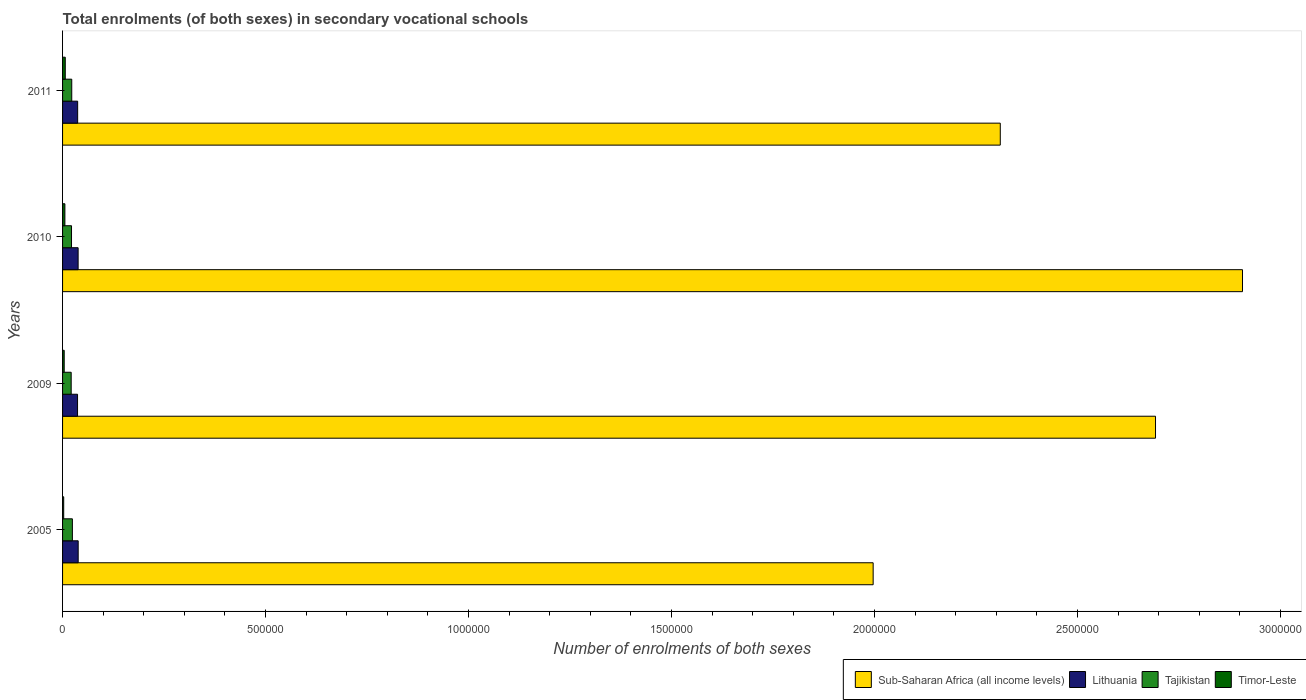How many different coloured bars are there?
Make the answer very short. 4. Are the number of bars on each tick of the Y-axis equal?
Your answer should be compact. Yes. What is the number of enrolments in secondary schools in Tajikistan in 2010?
Ensure brevity in your answer.  2.20e+04. Across all years, what is the maximum number of enrolments in secondary schools in Sub-Saharan Africa (all income levels)?
Your answer should be compact. 2.91e+06. Across all years, what is the minimum number of enrolments in secondary schools in Sub-Saharan Africa (all income levels)?
Give a very brief answer. 2.00e+06. In which year was the number of enrolments in secondary schools in Timor-Leste maximum?
Give a very brief answer. 2011. What is the total number of enrolments in secondary schools in Tajikistan in the graph?
Provide a short and direct response. 9.01e+04. What is the difference between the number of enrolments in secondary schools in Lithuania in 2009 and that in 2010?
Give a very brief answer. -1429. What is the difference between the number of enrolments in secondary schools in Timor-Leste in 2005 and the number of enrolments in secondary schools in Sub-Saharan Africa (all income levels) in 2009?
Provide a short and direct response. -2.69e+06. What is the average number of enrolments in secondary schools in Lithuania per year?
Your answer should be very brief. 3.77e+04. In the year 2005, what is the difference between the number of enrolments in secondary schools in Sub-Saharan Africa (all income levels) and number of enrolments in secondary schools in Tajikistan?
Offer a terse response. 1.97e+06. In how many years, is the number of enrolments in secondary schools in Tajikistan greater than 2900000 ?
Your answer should be compact. 0. What is the ratio of the number of enrolments in secondary schools in Lithuania in 2009 to that in 2011?
Keep it short and to the point. 0.99. Is the number of enrolments in secondary schools in Timor-Leste in 2009 less than that in 2011?
Your response must be concise. Yes. Is the difference between the number of enrolments in secondary schools in Sub-Saharan Africa (all income levels) in 2009 and 2010 greater than the difference between the number of enrolments in secondary schools in Tajikistan in 2009 and 2010?
Keep it short and to the point. No. What is the difference between the highest and the second highest number of enrolments in secondary schools in Timor-Leste?
Ensure brevity in your answer.  930. What is the difference between the highest and the lowest number of enrolments in secondary schools in Lithuania?
Give a very brief answer. 1573. Is it the case that in every year, the sum of the number of enrolments in secondary schools in Sub-Saharan Africa (all income levels) and number of enrolments in secondary schools in Tajikistan is greater than the sum of number of enrolments in secondary schools in Lithuania and number of enrolments in secondary schools in Timor-Leste?
Offer a terse response. Yes. What does the 3rd bar from the top in 2010 represents?
Your answer should be compact. Lithuania. What does the 4th bar from the bottom in 2011 represents?
Provide a short and direct response. Timor-Leste. Is it the case that in every year, the sum of the number of enrolments in secondary schools in Lithuania and number of enrolments in secondary schools in Sub-Saharan Africa (all income levels) is greater than the number of enrolments in secondary schools in Tajikistan?
Ensure brevity in your answer.  Yes. How many bars are there?
Offer a very short reply. 16. What is the difference between two consecutive major ticks on the X-axis?
Offer a terse response. 5.00e+05. Does the graph contain any zero values?
Offer a terse response. No. Does the graph contain grids?
Your response must be concise. No. Where does the legend appear in the graph?
Provide a short and direct response. Bottom right. How many legend labels are there?
Make the answer very short. 4. How are the legend labels stacked?
Offer a very short reply. Horizontal. What is the title of the graph?
Provide a short and direct response. Total enrolments (of both sexes) in secondary vocational schools. Does "Latin America(developing only)" appear as one of the legend labels in the graph?
Provide a short and direct response. No. What is the label or title of the X-axis?
Keep it short and to the point. Number of enrolments of both sexes. What is the Number of enrolments of both sexes in Sub-Saharan Africa (all income levels) in 2005?
Make the answer very short. 2.00e+06. What is the Number of enrolments of both sexes in Lithuania in 2005?
Offer a terse response. 3.85e+04. What is the Number of enrolments of both sexes in Tajikistan in 2005?
Keep it short and to the point. 2.42e+04. What is the Number of enrolments of both sexes in Timor-Leste in 2005?
Keep it short and to the point. 2800. What is the Number of enrolments of both sexes in Sub-Saharan Africa (all income levels) in 2009?
Give a very brief answer. 2.69e+06. What is the Number of enrolments of both sexes in Lithuania in 2009?
Your answer should be very brief. 3.69e+04. What is the Number of enrolments of both sexes of Tajikistan in 2009?
Provide a succinct answer. 2.12e+04. What is the Number of enrolments of both sexes in Timor-Leste in 2009?
Ensure brevity in your answer.  4044. What is the Number of enrolments of both sexes of Sub-Saharan Africa (all income levels) in 2010?
Ensure brevity in your answer.  2.91e+06. What is the Number of enrolments of both sexes in Lithuania in 2010?
Keep it short and to the point. 3.83e+04. What is the Number of enrolments of both sexes in Tajikistan in 2010?
Give a very brief answer. 2.20e+04. What is the Number of enrolments of both sexes of Timor-Leste in 2010?
Your answer should be compact. 5719. What is the Number of enrolments of both sexes in Sub-Saharan Africa (all income levels) in 2011?
Your answer should be very brief. 2.31e+06. What is the Number of enrolments of both sexes of Lithuania in 2011?
Provide a succinct answer. 3.72e+04. What is the Number of enrolments of both sexes in Tajikistan in 2011?
Keep it short and to the point. 2.26e+04. What is the Number of enrolments of both sexes in Timor-Leste in 2011?
Your answer should be compact. 6649. Across all years, what is the maximum Number of enrolments of both sexes of Sub-Saharan Africa (all income levels)?
Offer a terse response. 2.91e+06. Across all years, what is the maximum Number of enrolments of both sexes of Lithuania?
Offer a very short reply. 3.85e+04. Across all years, what is the maximum Number of enrolments of both sexes in Tajikistan?
Make the answer very short. 2.42e+04. Across all years, what is the maximum Number of enrolments of both sexes in Timor-Leste?
Your answer should be compact. 6649. Across all years, what is the minimum Number of enrolments of both sexes in Sub-Saharan Africa (all income levels)?
Provide a succinct answer. 2.00e+06. Across all years, what is the minimum Number of enrolments of both sexes of Lithuania?
Keep it short and to the point. 3.69e+04. Across all years, what is the minimum Number of enrolments of both sexes of Tajikistan?
Keep it short and to the point. 2.12e+04. Across all years, what is the minimum Number of enrolments of both sexes of Timor-Leste?
Give a very brief answer. 2800. What is the total Number of enrolments of both sexes in Sub-Saharan Africa (all income levels) in the graph?
Provide a short and direct response. 9.91e+06. What is the total Number of enrolments of both sexes of Lithuania in the graph?
Your answer should be compact. 1.51e+05. What is the total Number of enrolments of both sexes in Tajikistan in the graph?
Provide a short and direct response. 9.01e+04. What is the total Number of enrolments of both sexes in Timor-Leste in the graph?
Your answer should be compact. 1.92e+04. What is the difference between the Number of enrolments of both sexes in Sub-Saharan Africa (all income levels) in 2005 and that in 2009?
Provide a succinct answer. -6.96e+05. What is the difference between the Number of enrolments of both sexes in Lithuania in 2005 and that in 2009?
Provide a succinct answer. 1573. What is the difference between the Number of enrolments of both sexes in Tajikistan in 2005 and that in 2009?
Ensure brevity in your answer.  2952. What is the difference between the Number of enrolments of both sexes in Timor-Leste in 2005 and that in 2009?
Offer a terse response. -1244. What is the difference between the Number of enrolments of both sexes in Sub-Saharan Africa (all income levels) in 2005 and that in 2010?
Offer a very short reply. -9.10e+05. What is the difference between the Number of enrolments of both sexes of Lithuania in 2005 and that in 2010?
Provide a short and direct response. 144. What is the difference between the Number of enrolments of both sexes of Tajikistan in 2005 and that in 2010?
Offer a very short reply. 2167. What is the difference between the Number of enrolments of both sexes in Timor-Leste in 2005 and that in 2010?
Keep it short and to the point. -2919. What is the difference between the Number of enrolments of both sexes of Sub-Saharan Africa (all income levels) in 2005 and that in 2011?
Provide a succinct answer. -3.13e+05. What is the difference between the Number of enrolments of both sexes of Lithuania in 2005 and that in 2011?
Offer a terse response. 1291. What is the difference between the Number of enrolments of both sexes of Tajikistan in 2005 and that in 2011?
Offer a terse response. 1565. What is the difference between the Number of enrolments of both sexes of Timor-Leste in 2005 and that in 2011?
Your answer should be compact. -3849. What is the difference between the Number of enrolments of both sexes of Sub-Saharan Africa (all income levels) in 2009 and that in 2010?
Provide a succinct answer. -2.14e+05. What is the difference between the Number of enrolments of both sexes of Lithuania in 2009 and that in 2010?
Make the answer very short. -1429. What is the difference between the Number of enrolments of both sexes of Tajikistan in 2009 and that in 2010?
Your response must be concise. -785. What is the difference between the Number of enrolments of both sexes of Timor-Leste in 2009 and that in 2010?
Offer a very short reply. -1675. What is the difference between the Number of enrolments of both sexes of Sub-Saharan Africa (all income levels) in 2009 and that in 2011?
Keep it short and to the point. 3.82e+05. What is the difference between the Number of enrolments of both sexes of Lithuania in 2009 and that in 2011?
Your answer should be compact. -282. What is the difference between the Number of enrolments of both sexes in Tajikistan in 2009 and that in 2011?
Ensure brevity in your answer.  -1387. What is the difference between the Number of enrolments of both sexes of Timor-Leste in 2009 and that in 2011?
Keep it short and to the point. -2605. What is the difference between the Number of enrolments of both sexes in Sub-Saharan Africa (all income levels) in 2010 and that in 2011?
Your answer should be compact. 5.97e+05. What is the difference between the Number of enrolments of both sexes in Lithuania in 2010 and that in 2011?
Keep it short and to the point. 1147. What is the difference between the Number of enrolments of both sexes in Tajikistan in 2010 and that in 2011?
Keep it short and to the point. -602. What is the difference between the Number of enrolments of both sexes of Timor-Leste in 2010 and that in 2011?
Ensure brevity in your answer.  -930. What is the difference between the Number of enrolments of both sexes of Sub-Saharan Africa (all income levels) in 2005 and the Number of enrolments of both sexes of Lithuania in 2009?
Provide a succinct answer. 1.96e+06. What is the difference between the Number of enrolments of both sexes of Sub-Saharan Africa (all income levels) in 2005 and the Number of enrolments of both sexes of Tajikistan in 2009?
Your response must be concise. 1.98e+06. What is the difference between the Number of enrolments of both sexes of Sub-Saharan Africa (all income levels) in 2005 and the Number of enrolments of both sexes of Timor-Leste in 2009?
Offer a terse response. 1.99e+06. What is the difference between the Number of enrolments of both sexes in Lithuania in 2005 and the Number of enrolments of both sexes in Tajikistan in 2009?
Provide a succinct answer. 1.72e+04. What is the difference between the Number of enrolments of both sexes of Lithuania in 2005 and the Number of enrolments of both sexes of Timor-Leste in 2009?
Give a very brief answer. 3.44e+04. What is the difference between the Number of enrolments of both sexes in Tajikistan in 2005 and the Number of enrolments of both sexes in Timor-Leste in 2009?
Keep it short and to the point. 2.02e+04. What is the difference between the Number of enrolments of both sexes in Sub-Saharan Africa (all income levels) in 2005 and the Number of enrolments of both sexes in Lithuania in 2010?
Keep it short and to the point. 1.96e+06. What is the difference between the Number of enrolments of both sexes of Sub-Saharan Africa (all income levels) in 2005 and the Number of enrolments of both sexes of Tajikistan in 2010?
Your answer should be compact. 1.97e+06. What is the difference between the Number of enrolments of both sexes of Sub-Saharan Africa (all income levels) in 2005 and the Number of enrolments of both sexes of Timor-Leste in 2010?
Your response must be concise. 1.99e+06. What is the difference between the Number of enrolments of both sexes of Lithuania in 2005 and the Number of enrolments of both sexes of Tajikistan in 2010?
Offer a terse response. 1.64e+04. What is the difference between the Number of enrolments of both sexes of Lithuania in 2005 and the Number of enrolments of both sexes of Timor-Leste in 2010?
Provide a short and direct response. 3.27e+04. What is the difference between the Number of enrolments of both sexes of Tajikistan in 2005 and the Number of enrolments of both sexes of Timor-Leste in 2010?
Offer a terse response. 1.85e+04. What is the difference between the Number of enrolments of both sexes of Sub-Saharan Africa (all income levels) in 2005 and the Number of enrolments of both sexes of Lithuania in 2011?
Give a very brief answer. 1.96e+06. What is the difference between the Number of enrolments of both sexes in Sub-Saharan Africa (all income levels) in 2005 and the Number of enrolments of both sexes in Tajikistan in 2011?
Your response must be concise. 1.97e+06. What is the difference between the Number of enrolments of both sexes in Sub-Saharan Africa (all income levels) in 2005 and the Number of enrolments of both sexes in Timor-Leste in 2011?
Offer a very short reply. 1.99e+06. What is the difference between the Number of enrolments of both sexes in Lithuania in 2005 and the Number of enrolments of both sexes in Tajikistan in 2011?
Your answer should be very brief. 1.58e+04. What is the difference between the Number of enrolments of both sexes in Lithuania in 2005 and the Number of enrolments of both sexes in Timor-Leste in 2011?
Keep it short and to the point. 3.18e+04. What is the difference between the Number of enrolments of both sexes of Tajikistan in 2005 and the Number of enrolments of both sexes of Timor-Leste in 2011?
Offer a terse response. 1.75e+04. What is the difference between the Number of enrolments of both sexes in Sub-Saharan Africa (all income levels) in 2009 and the Number of enrolments of both sexes in Lithuania in 2010?
Offer a terse response. 2.65e+06. What is the difference between the Number of enrolments of both sexes in Sub-Saharan Africa (all income levels) in 2009 and the Number of enrolments of both sexes in Tajikistan in 2010?
Keep it short and to the point. 2.67e+06. What is the difference between the Number of enrolments of both sexes of Sub-Saharan Africa (all income levels) in 2009 and the Number of enrolments of both sexes of Timor-Leste in 2010?
Offer a terse response. 2.69e+06. What is the difference between the Number of enrolments of both sexes of Lithuania in 2009 and the Number of enrolments of both sexes of Tajikistan in 2010?
Ensure brevity in your answer.  1.49e+04. What is the difference between the Number of enrolments of both sexes in Lithuania in 2009 and the Number of enrolments of both sexes in Timor-Leste in 2010?
Offer a terse response. 3.12e+04. What is the difference between the Number of enrolments of both sexes of Tajikistan in 2009 and the Number of enrolments of both sexes of Timor-Leste in 2010?
Give a very brief answer. 1.55e+04. What is the difference between the Number of enrolments of both sexes in Sub-Saharan Africa (all income levels) in 2009 and the Number of enrolments of both sexes in Lithuania in 2011?
Give a very brief answer. 2.66e+06. What is the difference between the Number of enrolments of both sexes of Sub-Saharan Africa (all income levels) in 2009 and the Number of enrolments of both sexes of Tajikistan in 2011?
Provide a succinct answer. 2.67e+06. What is the difference between the Number of enrolments of both sexes in Sub-Saharan Africa (all income levels) in 2009 and the Number of enrolments of both sexes in Timor-Leste in 2011?
Ensure brevity in your answer.  2.69e+06. What is the difference between the Number of enrolments of both sexes of Lithuania in 2009 and the Number of enrolments of both sexes of Tajikistan in 2011?
Provide a succinct answer. 1.43e+04. What is the difference between the Number of enrolments of both sexes in Lithuania in 2009 and the Number of enrolments of both sexes in Timor-Leste in 2011?
Your answer should be compact. 3.02e+04. What is the difference between the Number of enrolments of both sexes of Tajikistan in 2009 and the Number of enrolments of both sexes of Timor-Leste in 2011?
Your answer should be compact. 1.46e+04. What is the difference between the Number of enrolments of both sexes in Sub-Saharan Africa (all income levels) in 2010 and the Number of enrolments of both sexes in Lithuania in 2011?
Ensure brevity in your answer.  2.87e+06. What is the difference between the Number of enrolments of both sexes in Sub-Saharan Africa (all income levels) in 2010 and the Number of enrolments of both sexes in Tajikistan in 2011?
Keep it short and to the point. 2.88e+06. What is the difference between the Number of enrolments of both sexes in Sub-Saharan Africa (all income levels) in 2010 and the Number of enrolments of both sexes in Timor-Leste in 2011?
Ensure brevity in your answer.  2.90e+06. What is the difference between the Number of enrolments of both sexes of Lithuania in 2010 and the Number of enrolments of both sexes of Tajikistan in 2011?
Your answer should be very brief. 1.57e+04. What is the difference between the Number of enrolments of both sexes of Lithuania in 2010 and the Number of enrolments of both sexes of Timor-Leste in 2011?
Make the answer very short. 3.17e+04. What is the difference between the Number of enrolments of both sexes of Tajikistan in 2010 and the Number of enrolments of both sexes of Timor-Leste in 2011?
Offer a terse response. 1.54e+04. What is the average Number of enrolments of both sexes in Sub-Saharan Africa (all income levels) per year?
Your answer should be compact. 2.48e+06. What is the average Number of enrolments of both sexes in Lithuania per year?
Make the answer very short. 3.77e+04. What is the average Number of enrolments of both sexes in Tajikistan per year?
Your answer should be very brief. 2.25e+04. What is the average Number of enrolments of both sexes of Timor-Leste per year?
Provide a succinct answer. 4803. In the year 2005, what is the difference between the Number of enrolments of both sexes in Sub-Saharan Africa (all income levels) and Number of enrolments of both sexes in Lithuania?
Ensure brevity in your answer.  1.96e+06. In the year 2005, what is the difference between the Number of enrolments of both sexes of Sub-Saharan Africa (all income levels) and Number of enrolments of both sexes of Tajikistan?
Give a very brief answer. 1.97e+06. In the year 2005, what is the difference between the Number of enrolments of both sexes in Sub-Saharan Africa (all income levels) and Number of enrolments of both sexes in Timor-Leste?
Offer a terse response. 1.99e+06. In the year 2005, what is the difference between the Number of enrolments of both sexes of Lithuania and Number of enrolments of both sexes of Tajikistan?
Make the answer very short. 1.43e+04. In the year 2005, what is the difference between the Number of enrolments of both sexes of Lithuania and Number of enrolments of both sexes of Timor-Leste?
Your answer should be compact. 3.57e+04. In the year 2005, what is the difference between the Number of enrolments of both sexes in Tajikistan and Number of enrolments of both sexes in Timor-Leste?
Offer a terse response. 2.14e+04. In the year 2009, what is the difference between the Number of enrolments of both sexes of Sub-Saharan Africa (all income levels) and Number of enrolments of both sexes of Lithuania?
Ensure brevity in your answer.  2.66e+06. In the year 2009, what is the difference between the Number of enrolments of both sexes of Sub-Saharan Africa (all income levels) and Number of enrolments of both sexes of Tajikistan?
Give a very brief answer. 2.67e+06. In the year 2009, what is the difference between the Number of enrolments of both sexes of Sub-Saharan Africa (all income levels) and Number of enrolments of both sexes of Timor-Leste?
Provide a succinct answer. 2.69e+06. In the year 2009, what is the difference between the Number of enrolments of both sexes of Lithuania and Number of enrolments of both sexes of Tajikistan?
Your answer should be very brief. 1.57e+04. In the year 2009, what is the difference between the Number of enrolments of both sexes of Lithuania and Number of enrolments of both sexes of Timor-Leste?
Offer a terse response. 3.29e+04. In the year 2009, what is the difference between the Number of enrolments of both sexes in Tajikistan and Number of enrolments of both sexes in Timor-Leste?
Keep it short and to the point. 1.72e+04. In the year 2010, what is the difference between the Number of enrolments of both sexes in Sub-Saharan Africa (all income levels) and Number of enrolments of both sexes in Lithuania?
Provide a short and direct response. 2.87e+06. In the year 2010, what is the difference between the Number of enrolments of both sexes of Sub-Saharan Africa (all income levels) and Number of enrolments of both sexes of Tajikistan?
Offer a terse response. 2.88e+06. In the year 2010, what is the difference between the Number of enrolments of both sexes in Sub-Saharan Africa (all income levels) and Number of enrolments of both sexes in Timor-Leste?
Keep it short and to the point. 2.90e+06. In the year 2010, what is the difference between the Number of enrolments of both sexes in Lithuania and Number of enrolments of both sexes in Tajikistan?
Offer a very short reply. 1.63e+04. In the year 2010, what is the difference between the Number of enrolments of both sexes of Lithuania and Number of enrolments of both sexes of Timor-Leste?
Your answer should be compact. 3.26e+04. In the year 2010, what is the difference between the Number of enrolments of both sexes in Tajikistan and Number of enrolments of both sexes in Timor-Leste?
Keep it short and to the point. 1.63e+04. In the year 2011, what is the difference between the Number of enrolments of both sexes of Sub-Saharan Africa (all income levels) and Number of enrolments of both sexes of Lithuania?
Keep it short and to the point. 2.27e+06. In the year 2011, what is the difference between the Number of enrolments of both sexes of Sub-Saharan Africa (all income levels) and Number of enrolments of both sexes of Tajikistan?
Offer a terse response. 2.29e+06. In the year 2011, what is the difference between the Number of enrolments of both sexes of Sub-Saharan Africa (all income levels) and Number of enrolments of both sexes of Timor-Leste?
Offer a terse response. 2.30e+06. In the year 2011, what is the difference between the Number of enrolments of both sexes in Lithuania and Number of enrolments of both sexes in Tajikistan?
Your response must be concise. 1.45e+04. In the year 2011, what is the difference between the Number of enrolments of both sexes of Lithuania and Number of enrolments of both sexes of Timor-Leste?
Keep it short and to the point. 3.05e+04. In the year 2011, what is the difference between the Number of enrolments of both sexes of Tajikistan and Number of enrolments of both sexes of Timor-Leste?
Offer a very short reply. 1.60e+04. What is the ratio of the Number of enrolments of both sexes in Sub-Saharan Africa (all income levels) in 2005 to that in 2009?
Offer a terse response. 0.74. What is the ratio of the Number of enrolments of both sexes in Lithuania in 2005 to that in 2009?
Your answer should be compact. 1.04. What is the ratio of the Number of enrolments of both sexes of Tajikistan in 2005 to that in 2009?
Provide a short and direct response. 1.14. What is the ratio of the Number of enrolments of both sexes of Timor-Leste in 2005 to that in 2009?
Provide a short and direct response. 0.69. What is the ratio of the Number of enrolments of both sexes in Sub-Saharan Africa (all income levels) in 2005 to that in 2010?
Make the answer very short. 0.69. What is the ratio of the Number of enrolments of both sexes of Tajikistan in 2005 to that in 2010?
Make the answer very short. 1.1. What is the ratio of the Number of enrolments of both sexes in Timor-Leste in 2005 to that in 2010?
Your answer should be very brief. 0.49. What is the ratio of the Number of enrolments of both sexes in Sub-Saharan Africa (all income levels) in 2005 to that in 2011?
Offer a terse response. 0.86. What is the ratio of the Number of enrolments of both sexes of Lithuania in 2005 to that in 2011?
Provide a short and direct response. 1.03. What is the ratio of the Number of enrolments of both sexes of Tajikistan in 2005 to that in 2011?
Your answer should be very brief. 1.07. What is the ratio of the Number of enrolments of both sexes in Timor-Leste in 2005 to that in 2011?
Your answer should be compact. 0.42. What is the ratio of the Number of enrolments of both sexes in Sub-Saharan Africa (all income levels) in 2009 to that in 2010?
Your answer should be compact. 0.93. What is the ratio of the Number of enrolments of both sexes of Lithuania in 2009 to that in 2010?
Ensure brevity in your answer.  0.96. What is the ratio of the Number of enrolments of both sexes in Tajikistan in 2009 to that in 2010?
Make the answer very short. 0.96. What is the ratio of the Number of enrolments of both sexes of Timor-Leste in 2009 to that in 2010?
Offer a terse response. 0.71. What is the ratio of the Number of enrolments of both sexes in Sub-Saharan Africa (all income levels) in 2009 to that in 2011?
Your answer should be very brief. 1.17. What is the ratio of the Number of enrolments of both sexes of Lithuania in 2009 to that in 2011?
Your answer should be compact. 0.99. What is the ratio of the Number of enrolments of both sexes of Tajikistan in 2009 to that in 2011?
Provide a short and direct response. 0.94. What is the ratio of the Number of enrolments of both sexes of Timor-Leste in 2009 to that in 2011?
Make the answer very short. 0.61. What is the ratio of the Number of enrolments of both sexes in Sub-Saharan Africa (all income levels) in 2010 to that in 2011?
Your answer should be compact. 1.26. What is the ratio of the Number of enrolments of both sexes in Lithuania in 2010 to that in 2011?
Ensure brevity in your answer.  1.03. What is the ratio of the Number of enrolments of both sexes in Tajikistan in 2010 to that in 2011?
Offer a very short reply. 0.97. What is the ratio of the Number of enrolments of both sexes in Timor-Leste in 2010 to that in 2011?
Your response must be concise. 0.86. What is the difference between the highest and the second highest Number of enrolments of both sexes in Sub-Saharan Africa (all income levels)?
Offer a terse response. 2.14e+05. What is the difference between the highest and the second highest Number of enrolments of both sexes of Lithuania?
Offer a very short reply. 144. What is the difference between the highest and the second highest Number of enrolments of both sexes of Tajikistan?
Your response must be concise. 1565. What is the difference between the highest and the second highest Number of enrolments of both sexes in Timor-Leste?
Your answer should be compact. 930. What is the difference between the highest and the lowest Number of enrolments of both sexes in Sub-Saharan Africa (all income levels)?
Provide a short and direct response. 9.10e+05. What is the difference between the highest and the lowest Number of enrolments of both sexes of Lithuania?
Make the answer very short. 1573. What is the difference between the highest and the lowest Number of enrolments of both sexes of Tajikistan?
Keep it short and to the point. 2952. What is the difference between the highest and the lowest Number of enrolments of both sexes of Timor-Leste?
Your answer should be very brief. 3849. 